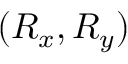<formula> <loc_0><loc_0><loc_500><loc_500>( R _ { x } , R _ { y } )</formula> 